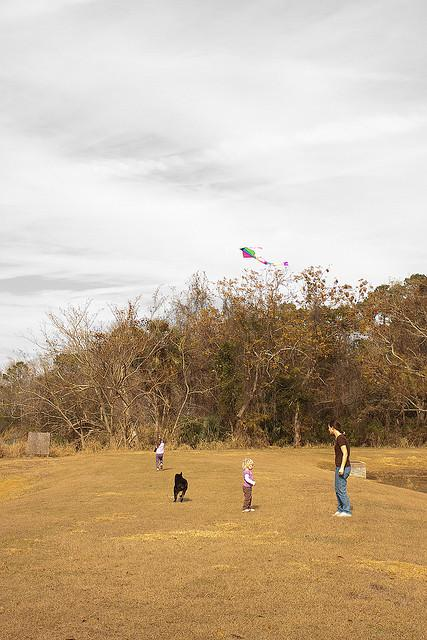What breed dog it is? Please explain your reasoning. cane corso. The dog is black with upright ears which is typical of a cane corso dog. 